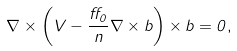<formula> <loc_0><loc_0><loc_500><loc_500>\nabla \times \left ( { V } - \frac { \alpha _ { 0 } } { n } \nabla \times { b } \right ) \times { b } = 0 ,</formula> 